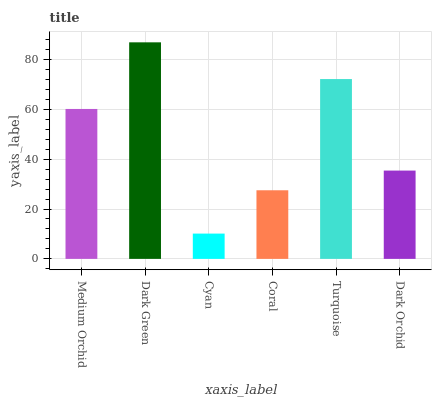Is Cyan the minimum?
Answer yes or no. Yes. Is Dark Green the maximum?
Answer yes or no. Yes. Is Dark Green the minimum?
Answer yes or no. No. Is Cyan the maximum?
Answer yes or no. No. Is Dark Green greater than Cyan?
Answer yes or no. Yes. Is Cyan less than Dark Green?
Answer yes or no. Yes. Is Cyan greater than Dark Green?
Answer yes or no. No. Is Dark Green less than Cyan?
Answer yes or no. No. Is Medium Orchid the high median?
Answer yes or no. Yes. Is Dark Orchid the low median?
Answer yes or no. Yes. Is Cyan the high median?
Answer yes or no. No. Is Coral the low median?
Answer yes or no. No. 